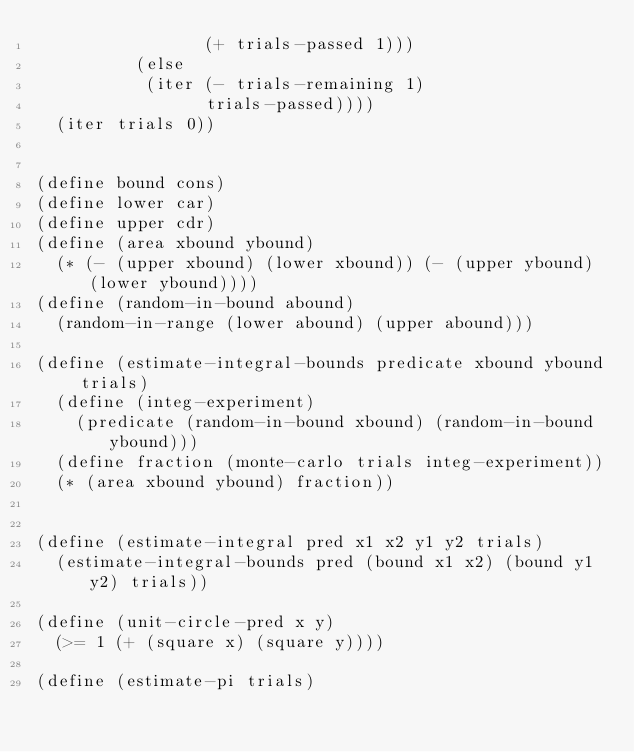Convert code to text. <code><loc_0><loc_0><loc_500><loc_500><_Scheme_>                 (+ trials-passed 1)))
          (else
           (iter (- trials-remaining 1) 
                 trials-passed))))
  (iter trials 0))


(define bound cons)
(define lower car)
(define upper cdr)
(define (area xbound ybound)
  (* (- (upper xbound) (lower xbound)) (- (upper ybound) (lower ybound))))
(define (random-in-bound abound)
  (random-in-range (lower abound) (upper abound)))

(define (estimate-integral-bounds predicate xbound ybound trials)
  (define (integ-experiment)
    (predicate (random-in-bound xbound) (random-in-bound ybound)))
  (define fraction (monte-carlo trials integ-experiment))
  (* (area xbound ybound) fraction))


(define (estimate-integral pred x1 x2 y1 y2 trials)
  (estimate-integral-bounds pred (bound x1 x2) (bound y1 y2) trials))

(define (unit-circle-pred x y)
  (>= 1 (+ (square x) (square y))))

(define (estimate-pi trials)</code> 